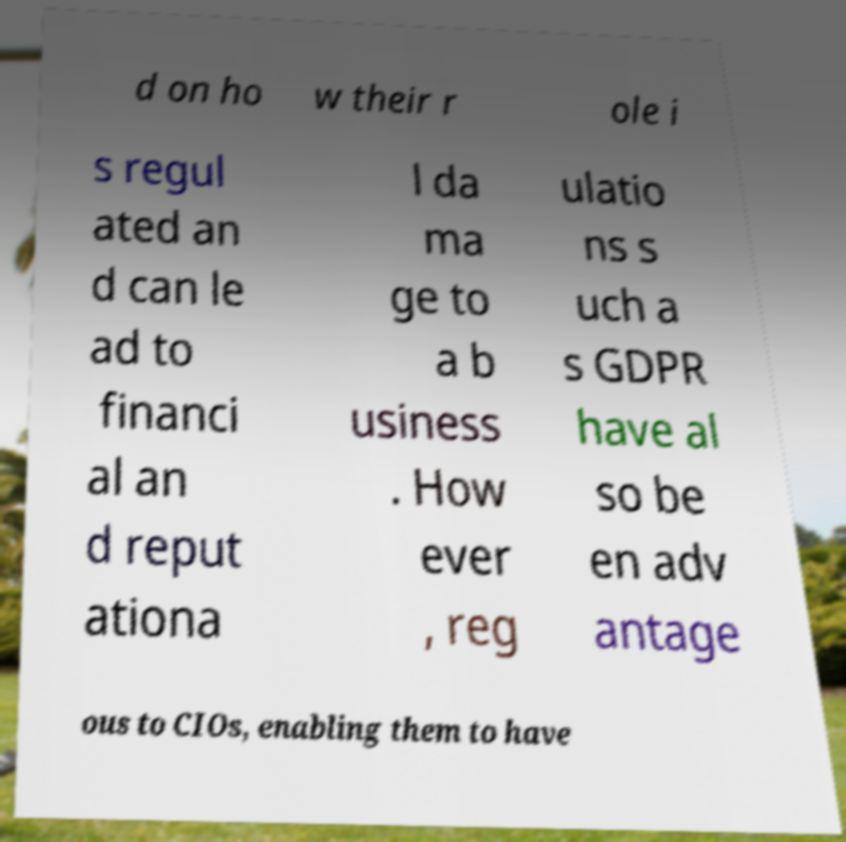Can you read and provide the text displayed in the image?This photo seems to have some interesting text. Can you extract and type it out for me? d on ho w their r ole i s regul ated an d can le ad to financi al an d reput ationa l da ma ge to a b usiness . How ever , reg ulatio ns s uch a s GDPR have al so be en adv antage ous to CIOs, enabling them to have 